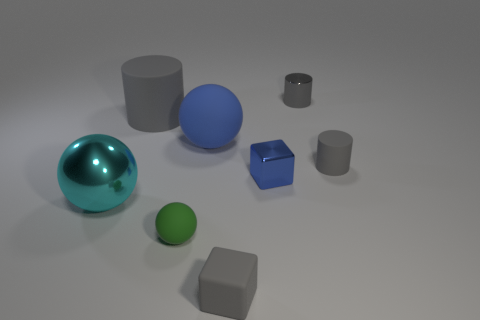There is a sphere that is the same color as the small shiny cube; what material is it?
Give a very brief answer. Rubber. Is the color of the tiny matte cube the same as the small shiny cylinder?
Keep it short and to the point. Yes. There is a matte sphere that is behind the big metal ball; does it have the same color as the small metallic cube?
Provide a short and direct response. Yes. What is the size of the cube that is the same color as the tiny metallic cylinder?
Your response must be concise. Small. There is a sphere that is in front of the large cyan metallic sphere; is its color the same as the small thing that is behind the small gray rubber cylinder?
Provide a succinct answer. No. How big is the metal cube?
Provide a succinct answer. Small. How many large things are either gray cylinders or red cylinders?
Your answer should be compact. 1. There is a matte cylinder that is the same size as the cyan thing; what color is it?
Your response must be concise. Gray. How many other objects are the same shape as the tiny blue thing?
Ensure brevity in your answer.  1. Are there any tiny gray cylinders made of the same material as the tiny sphere?
Your answer should be very brief. Yes. 